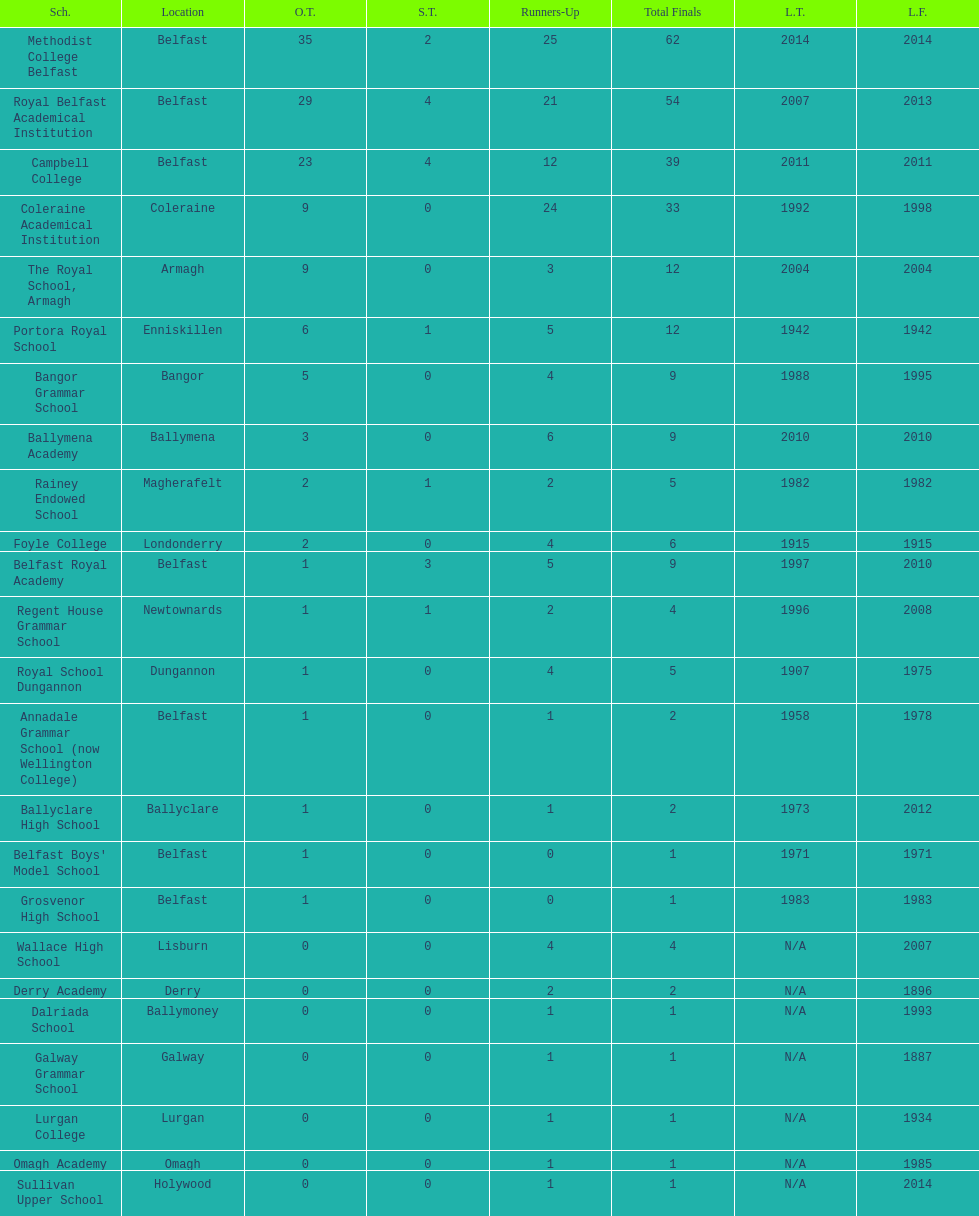Which school has the same number of outright titles as the coleraine academical institution? The Royal School, Armagh. 